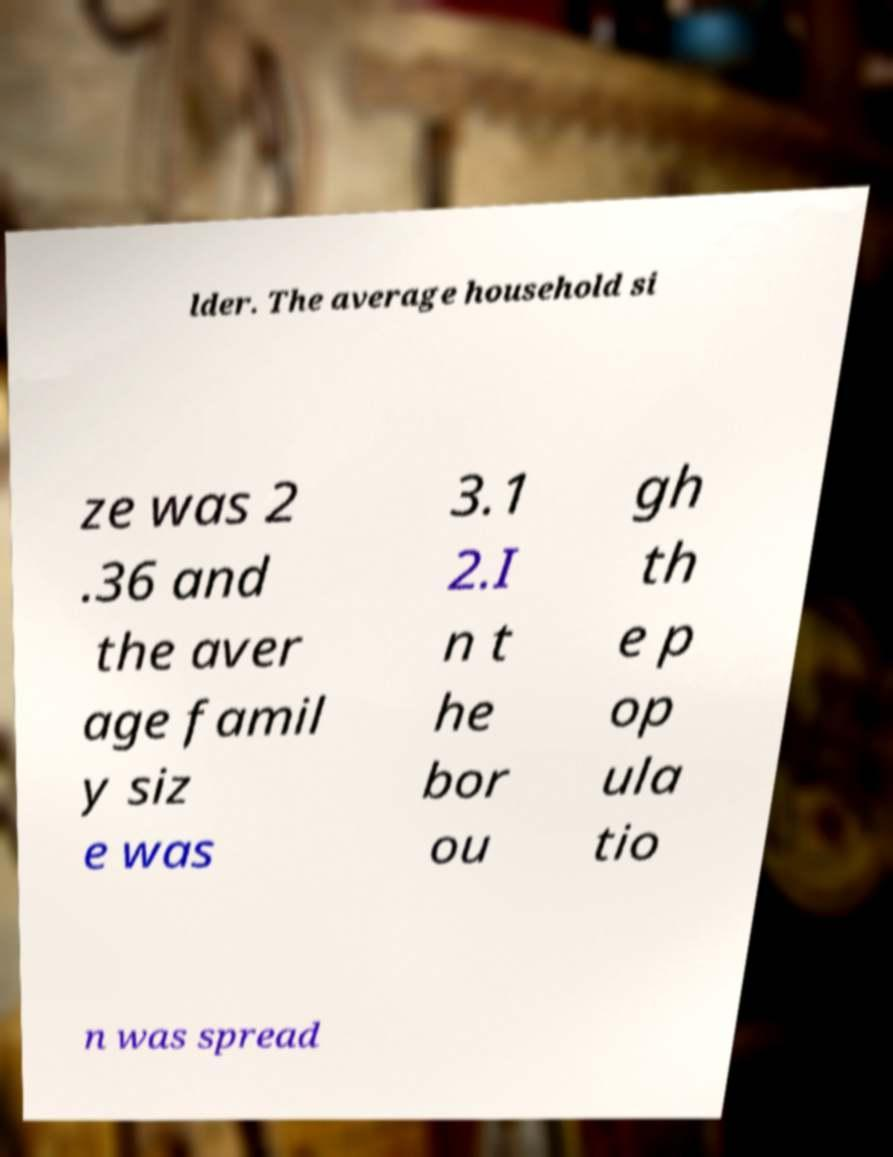I need the written content from this picture converted into text. Can you do that? lder. The average household si ze was 2 .36 and the aver age famil y siz e was 3.1 2.I n t he bor ou gh th e p op ula tio n was spread 